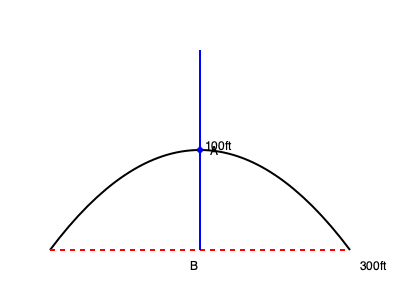As a NASCAR driver, you're approaching a curved section of the track. The curve can be approximated by a parabola, with a chord length of 300 feet and a maximum height of 100 feet at the midpoint. Calculate the radius of curvature at the apex (point A) of the turn to determine the optimal racing line. Round your answer to the nearest foot. To find the radius of curvature at the apex, we'll follow these steps:

1) The general equation of a parabola is $y = ax^2$, where $a$ is the coefficient we need to find.

2) We know that when $x = 150$ (half of 300), $y = 100$. Substituting these values:
   $100 = a(150)^2$
   $100 = 22500a$
   $a = \frac{100}{22500} = \frac{1}{225}$

3) So our parabola equation is $y = \frac{1}{225}x^2$

4) The formula for the radius of curvature (R) at any point on a parabola is:
   $R = \frac{[1 + (y')^2]^{3/2}}{|y''|}$

   Where $y'$ is the first derivative and $y''$ is the second derivative of the parabola equation.

5) $y' = \frac{2}{225}x$
   $y'' = \frac{2}{225}$

6) At the apex (x = 0), $y' = 0$

7) Substituting into the radius of curvature formula:
   $R = \frac{[1 + (0)^2]^{3/2}}{|\frac{2}{225}|} = \frac{1}{\frac{2}{225}} = 112.5$

8) Rounding to the nearest foot, we get 113 feet.
Answer: 113 feet 